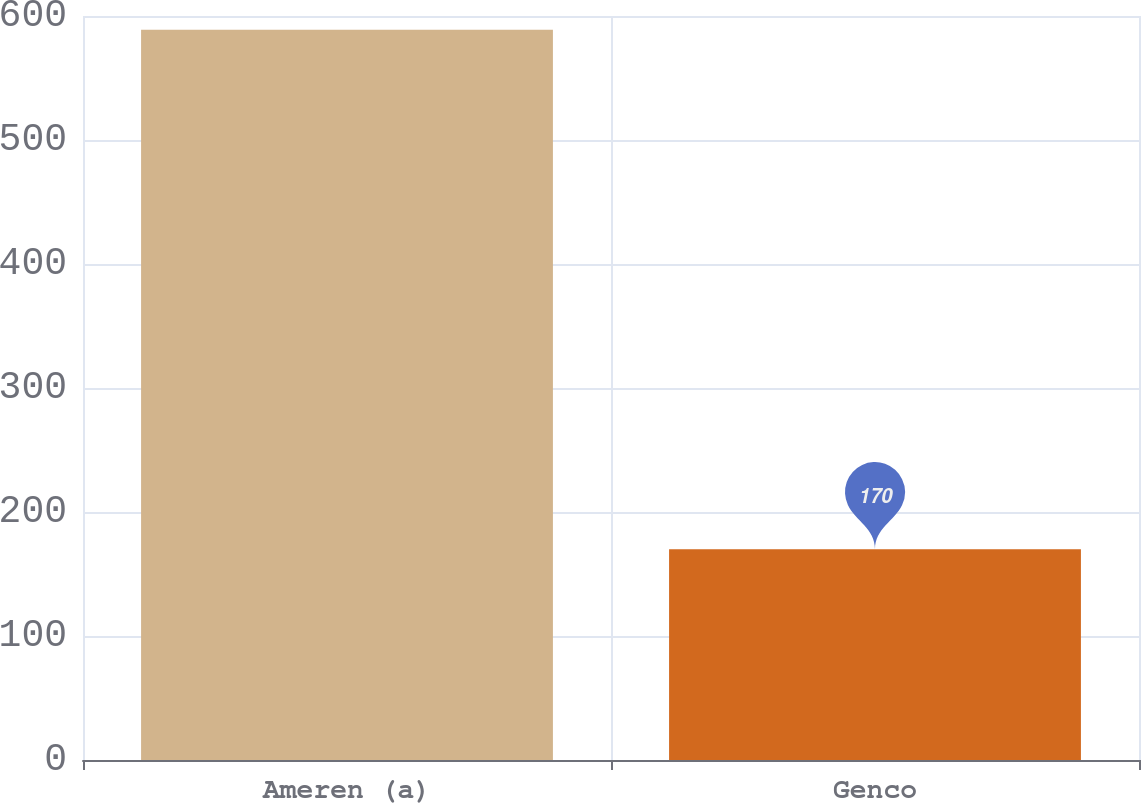Convert chart. <chart><loc_0><loc_0><loc_500><loc_500><bar_chart><fcel>Ameren (a)<fcel>Genco<nl><fcel>589<fcel>170<nl></chart> 